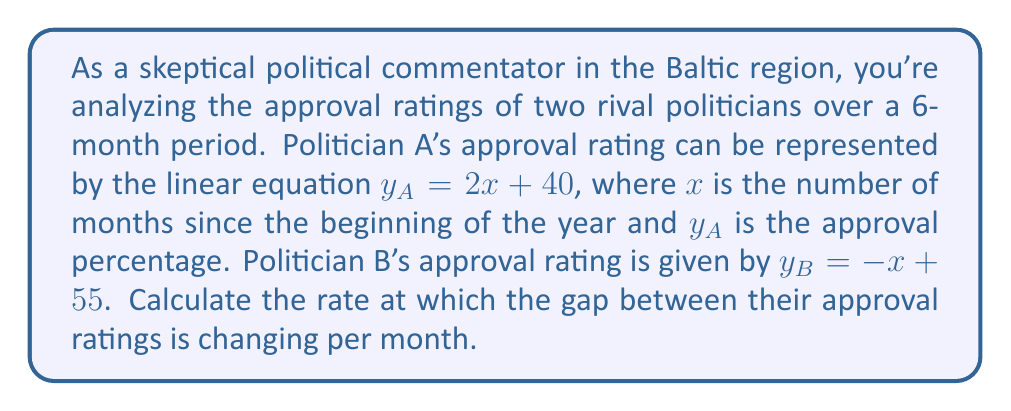Can you answer this question? To solve this problem, we need to follow these steps:

1) First, let's understand what the equations represent:
   For Politician A: $y_A = 2x + 40$
   For Politician B: $y_B = -x + 55$

2) The gap between their approval ratings at any given time is the difference between these two equations:
   $\text{Gap} = y_A - y_B = (2x + 40) - (-x + 55)$

3) Simplify this equation:
   $\text{Gap} = 2x + 40 + x - 55 = 3x - 15$

4) This equation, $3x - 15$, represents how the gap changes over time. The coefficient of $x$ in this equation gives us the rate of change per month.

5) Therefore, the rate of change of the gap is 3 percentage points per month.

6) Since we're asked about the rate at which the gap is changing, and Politician A's approval is increasing while Politician B's is decreasing, we can conclude that the gap is widening by 3 percentage points each month in favor of Politician A.
Answer: The gap between the approval ratings of the two politicians is widening at a rate of 3 percentage points per month in favor of Politician A. 